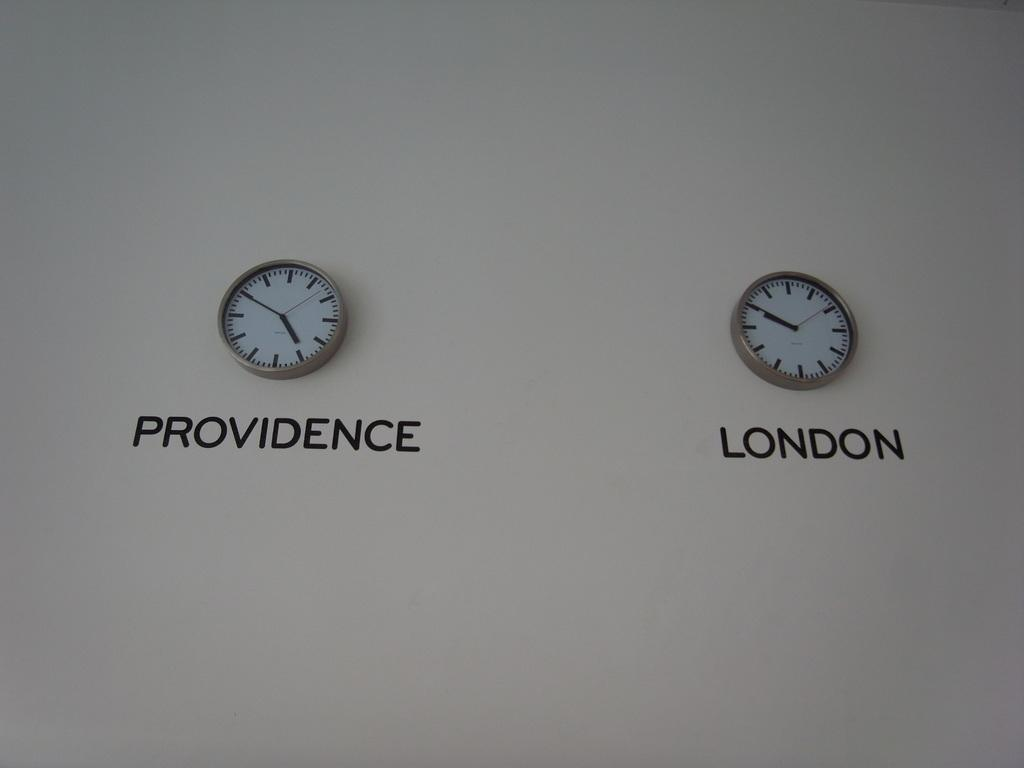<image>
Offer a succinct explanation of the picture presented. Two clocks on a wall showing times for Providence and London 